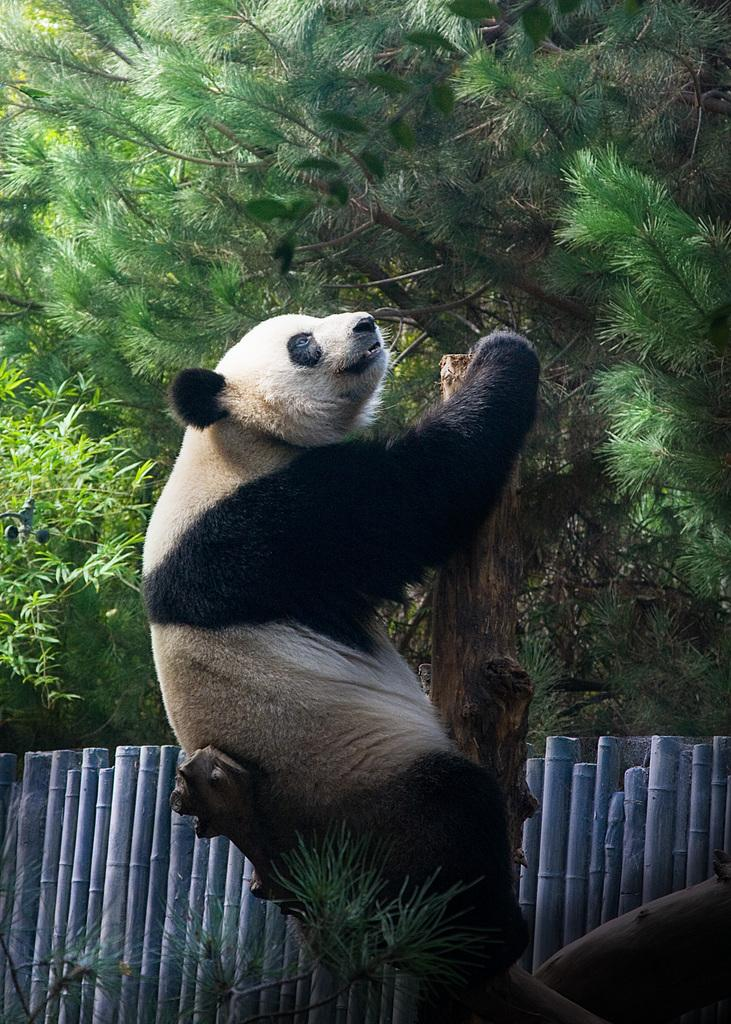What animal is the main subject of the image? There is a panda in the image. What is the panda doing in the image? The panda is sitting on a tree. What type of barrier can be seen in the image? There is a wooden fence in the image. What can be seen in the distance in the image? There are trees visible in the background of the image. What activity is the person engaging in with the panda in the image? There is no person present in the image; it features a panda sitting on a tree. What idea does the panda have about the wooden fence in the image? The panda does not have any ideas about the wooden fence, as it is an animal and cannot think or communicate like a person. 